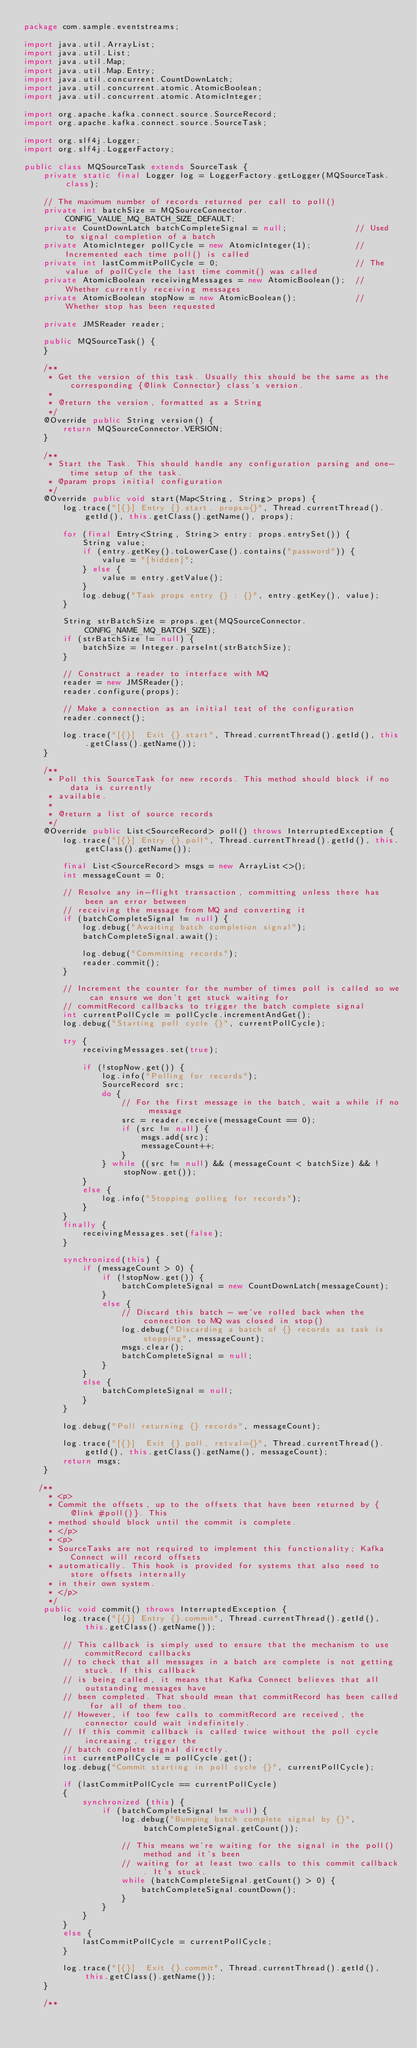<code> <loc_0><loc_0><loc_500><loc_500><_Java_>package com.sample.eventstreams;

import java.util.ArrayList;
import java.util.List;
import java.util.Map;
import java.util.Map.Entry;
import java.util.concurrent.CountDownLatch;
import java.util.concurrent.atomic.AtomicBoolean;
import java.util.concurrent.atomic.AtomicInteger;

import org.apache.kafka.connect.source.SourceRecord;
import org.apache.kafka.connect.source.SourceTask;

import org.slf4j.Logger;
import org.slf4j.LoggerFactory;

public class MQSourceTask extends SourceTask {
    private static final Logger log = LoggerFactory.getLogger(MQSourceTask.class);

    // The maximum number of records returned per call to poll()
    private int batchSize = MQSourceConnector.CONFIG_VALUE_MQ_BATCH_SIZE_DEFAULT;
    private CountDownLatch batchCompleteSignal = null;              // Used to signal completion of a batch
    private AtomicInteger pollCycle = new AtomicInteger(1);         // Incremented each time poll() is called
    private int lastCommitPollCycle = 0;                            // The value of pollCycle the last time commit() was called
    private AtomicBoolean receivingMessages = new AtomicBoolean();  // Whether currently receiving messages
    private AtomicBoolean stopNow = new AtomicBoolean();            // Whether stop has been requested

    private JMSReader reader;

    public MQSourceTask() {
    }

    /**
     * Get the version of this task. Usually this should be the same as the corresponding {@link Connector} class's version.
     *
     * @return the version, formatted as a String
     */
    @Override public String version() {
        return MQSourceConnector.VERSION;
    }

    /**
     * Start the Task. This should handle any configuration parsing and one-time setup of the task.
     * @param props initial configuration
     */
    @Override public void start(Map<String, String> props) {
        log.trace("[{}] Entry {}.start, props={}", Thread.currentThread().getId(), this.getClass().getName(), props);

        for (final Entry<String, String> entry: props.entrySet()) {
            String value;
            if (entry.getKey().toLowerCase().contains("password")) {
                value = "[hidden]";
            } else {
                value = entry.getValue();
            }
            log.debug("Task props entry {} : {}", entry.getKey(), value);
        }

        String strBatchSize = props.get(MQSourceConnector.CONFIG_NAME_MQ_BATCH_SIZE);
        if (strBatchSize != null) {
            batchSize = Integer.parseInt(strBatchSize);
        }

        // Construct a reader to interface with MQ
        reader = new JMSReader();
        reader.configure(props);

        // Make a connection as an initial test of the configuration
        reader.connect();

        log.trace("[{}]  Exit {}.start", Thread.currentThread().getId(), this.getClass().getName());
    }

    /**
     * Poll this SourceTask for new records. This method should block if no data is currently
     * available.
     *
     * @return a list of source records
     */
    @Override public List<SourceRecord> poll() throws InterruptedException {
        log.trace("[{}] Entry {}.poll", Thread.currentThread().getId(), this.getClass().getName());

        final List<SourceRecord> msgs = new ArrayList<>();
        int messageCount = 0;

        // Resolve any in-flight transaction, committing unless there has been an error between
        // receiving the message from MQ and converting it
        if (batchCompleteSignal != null) {
            log.debug("Awaiting batch completion signal");
            batchCompleteSignal.await();

            log.debug("Committing records");
            reader.commit();
        }

        // Increment the counter for the number of times poll is called so we can ensure we don't get stuck waiting for
        // commitRecord callbacks to trigger the batch complete signal
        int currentPollCycle = pollCycle.incrementAndGet();
        log.debug("Starting poll cycle {}", currentPollCycle);

        try {
            receivingMessages.set(true);

            if (!stopNow.get()) {
                log.info("Polling for records");
                SourceRecord src;
                do {
                    // For the first message in the batch, wait a while if no message
                    src = reader.receive(messageCount == 0);
                    if (src != null) {
                        msgs.add(src);
                        messageCount++;
                    }
                } while ((src != null) && (messageCount < batchSize) && !stopNow.get());
            }
            else {
                log.info("Stopping polling for records");
            }
        }
        finally {
            receivingMessages.set(false);
        }

        synchronized(this) {
            if (messageCount > 0) {
                if (!stopNow.get()) {
                    batchCompleteSignal = new CountDownLatch(messageCount);
                }
                else {
                    // Discard this batch - we've rolled back when the connection to MQ was closed in stop()
                    log.debug("Discarding a batch of {} records as task is stopping", messageCount);
                    msgs.clear();
                    batchCompleteSignal = null;
                }
            }
            else {
                batchCompleteSignal = null;
            }
        }

        log.debug("Poll returning {} records", messageCount);

        log.trace("[{}]  Exit {}.poll, retval={}", Thread.currentThread().getId(), this.getClass().getName(), messageCount);
        return msgs;
    }

   /**
     * <p>
     * Commit the offsets, up to the offsets that have been returned by {@link #poll()}. This
     * method should block until the commit is complete.
     * </p>
     * <p>
     * SourceTasks are not required to implement this functionality; Kafka Connect will record offsets
     * automatically. This hook is provided for systems that also need to store offsets internally
     * in their own system.
     * </p>
     */
    public void commit() throws InterruptedException {
        log.trace("[{}] Entry {}.commit", Thread.currentThread().getId(), this.getClass().getName());

        // This callback is simply used to ensure that the mechanism to use commitRecord callbacks
        // to check that all messages in a batch are complete is not getting stuck. If this callback
        // is being called, it means that Kafka Connect believes that all outstanding messages have
        // been completed. That should mean that commitRecord has been called for all of them too.
        // However, if too few calls to commitRecord are received, the connector could wait indefinitely.
        // If this commit callback is called twice without the poll cycle increasing, trigger the
        // batch complete signal directly.
        int currentPollCycle = pollCycle.get();
        log.debug("Commit starting in poll cycle {}", currentPollCycle);

        if (lastCommitPollCycle == currentPollCycle)
        {
            synchronized (this) {
                if (batchCompleteSignal != null) {
                    log.debug("Bumping batch complete signal by {}", batchCompleteSignal.getCount());

                    // This means we're waiting for the signal in the poll() method and it's been
                    // waiting for at least two calls to this commit callback. It's stuck.
                    while (batchCompleteSignal.getCount() > 0) {
                        batchCompleteSignal.countDown();
                    }
                }
            }
        }
        else {
            lastCommitPollCycle = currentPollCycle;
        }

        log.trace("[{}]  Exit {}.commit", Thread.currentThread().getId(), this.getClass().getName());
    }

    /**</code> 